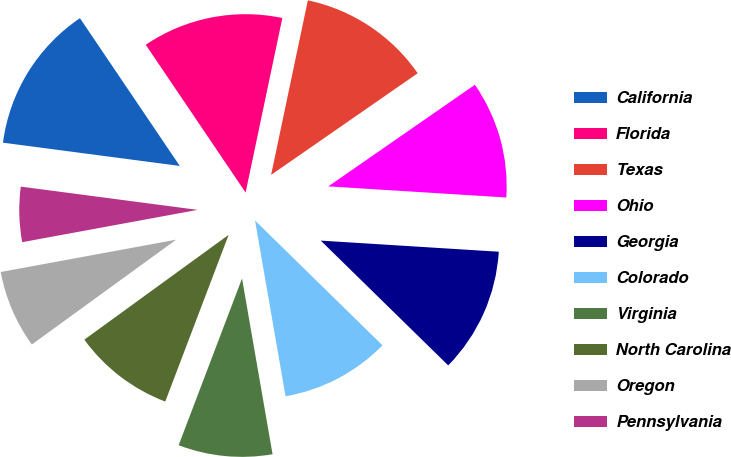<chart> <loc_0><loc_0><loc_500><loc_500><pie_chart><fcel>California<fcel>Florida<fcel>Texas<fcel>Ohio<fcel>Georgia<fcel>Colorado<fcel>Virginia<fcel>North Carolina<fcel>Oregon<fcel>Pennsylvania<nl><fcel>13.46%<fcel>12.76%<fcel>12.05%<fcel>10.64%<fcel>11.34%<fcel>9.93%<fcel>8.52%<fcel>9.22%<fcel>7.1%<fcel>4.98%<nl></chart> 